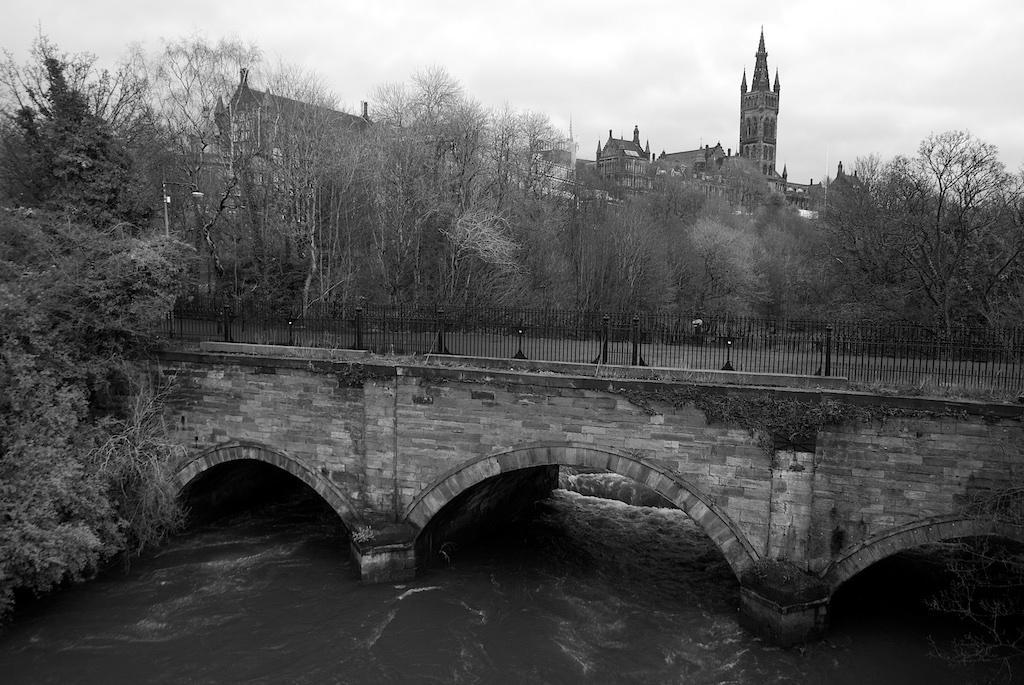How would you summarize this image in a sentence or two? In the foreground of this black and white image, there is a bridge under which water is flowing. In the background, there are trees, few buildings and the cloud. 